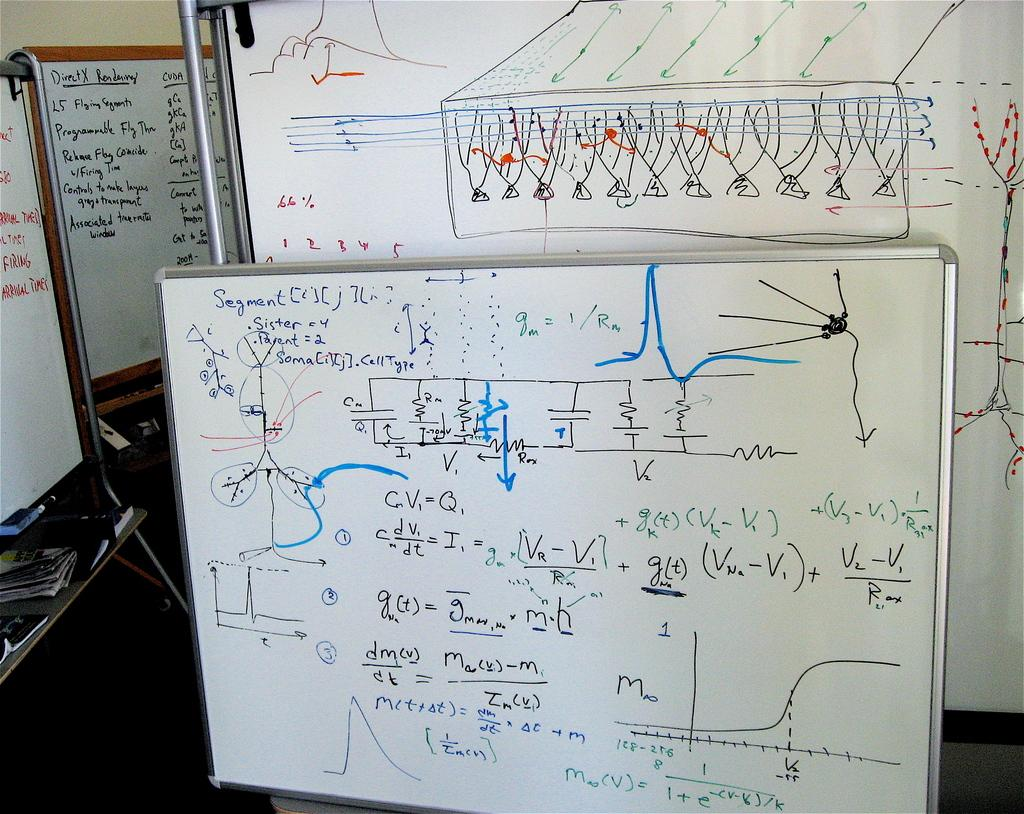<image>
Summarize the visual content of the image. A white marker board is propped against a wall with trigonometry instructions and problems written in black and blue. 